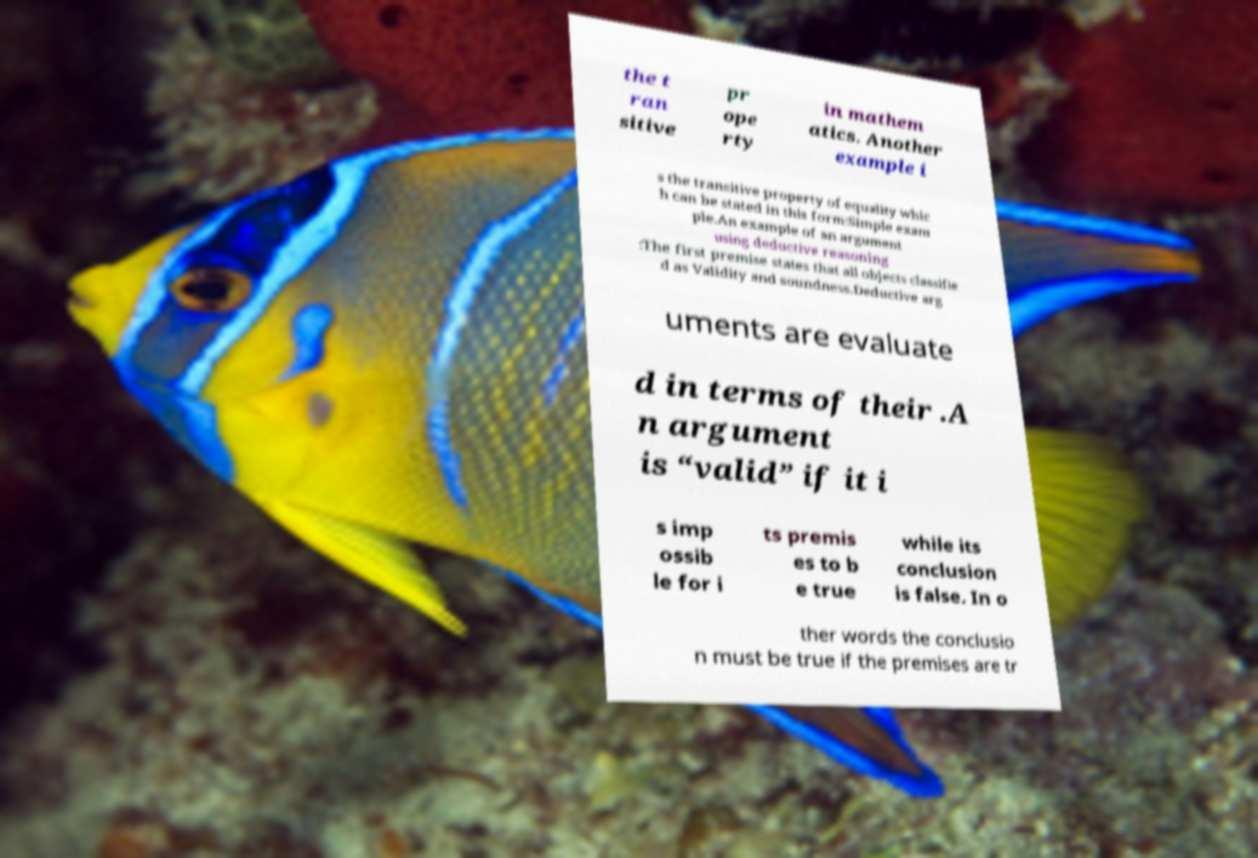Please read and relay the text visible in this image. What does it say? the t ran sitive pr ope rty in mathem atics. Another example i s the transitive property of equality whic h can be stated in this form:Simple exam ple.An example of an argument using deductive reasoning :The first premise states that all objects classifie d as Validity and soundness.Deductive arg uments are evaluate d in terms of their .A n argument is “valid” if it i s imp ossib le for i ts premis es to b e true while its conclusion is false. In o ther words the conclusio n must be true if the premises are tr 